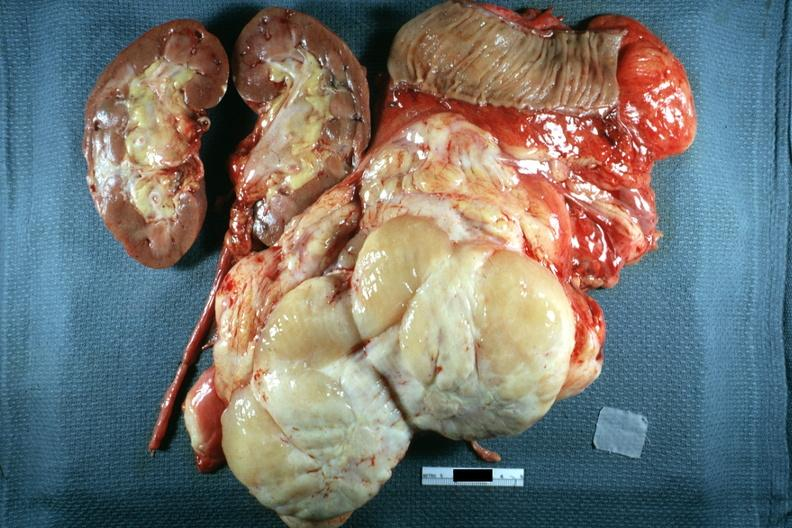where is this area in the body?
Answer the question using a single word or phrase. Abdomen 